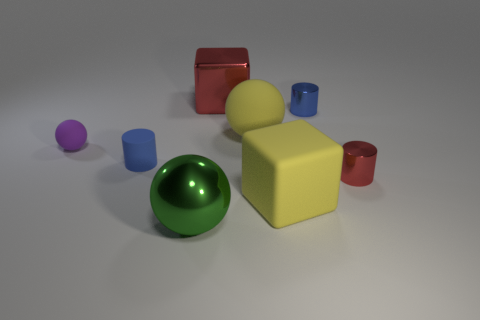Subtract all yellow balls. How many balls are left? 2 Subtract 1 cylinders. How many cylinders are left? 2 Subtract all cyan balls. Subtract all yellow cylinders. How many balls are left? 3 Add 1 big yellow blocks. How many objects exist? 9 Subtract all cubes. How many objects are left? 6 Add 2 small red metal cylinders. How many small red metal cylinders are left? 3 Add 7 tiny red metal balls. How many tiny red metal balls exist? 7 Subtract 1 green balls. How many objects are left? 7 Subtract all big yellow spheres. Subtract all tiny purple spheres. How many objects are left? 6 